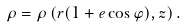Convert formula to latex. <formula><loc_0><loc_0><loc_500><loc_500>\rho = \rho \left ( r ( 1 + e \cos \varphi ) , z \right ) .</formula> 